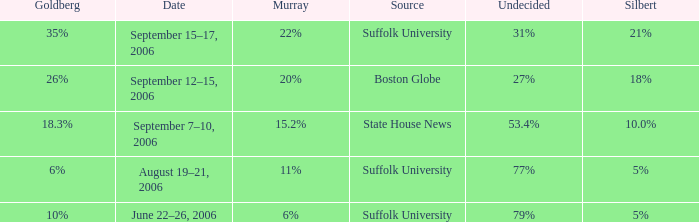What is the date of the poll with Silbert at 10.0%? September 7–10, 2006. 